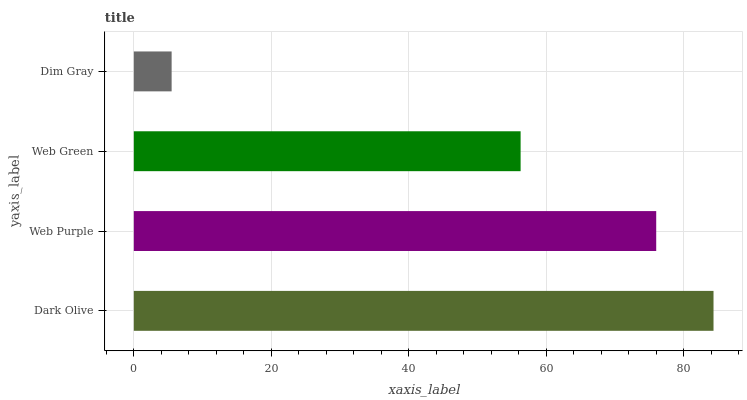Is Dim Gray the minimum?
Answer yes or no. Yes. Is Dark Olive the maximum?
Answer yes or no. Yes. Is Web Purple the minimum?
Answer yes or no. No. Is Web Purple the maximum?
Answer yes or no. No. Is Dark Olive greater than Web Purple?
Answer yes or no. Yes. Is Web Purple less than Dark Olive?
Answer yes or no. Yes. Is Web Purple greater than Dark Olive?
Answer yes or no. No. Is Dark Olive less than Web Purple?
Answer yes or no. No. Is Web Purple the high median?
Answer yes or no. Yes. Is Web Green the low median?
Answer yes or no. Yes. Is Web Green the high median?
Answer yes or no. No. Is Dim Gray the low median?
Answer yes or no. No. 